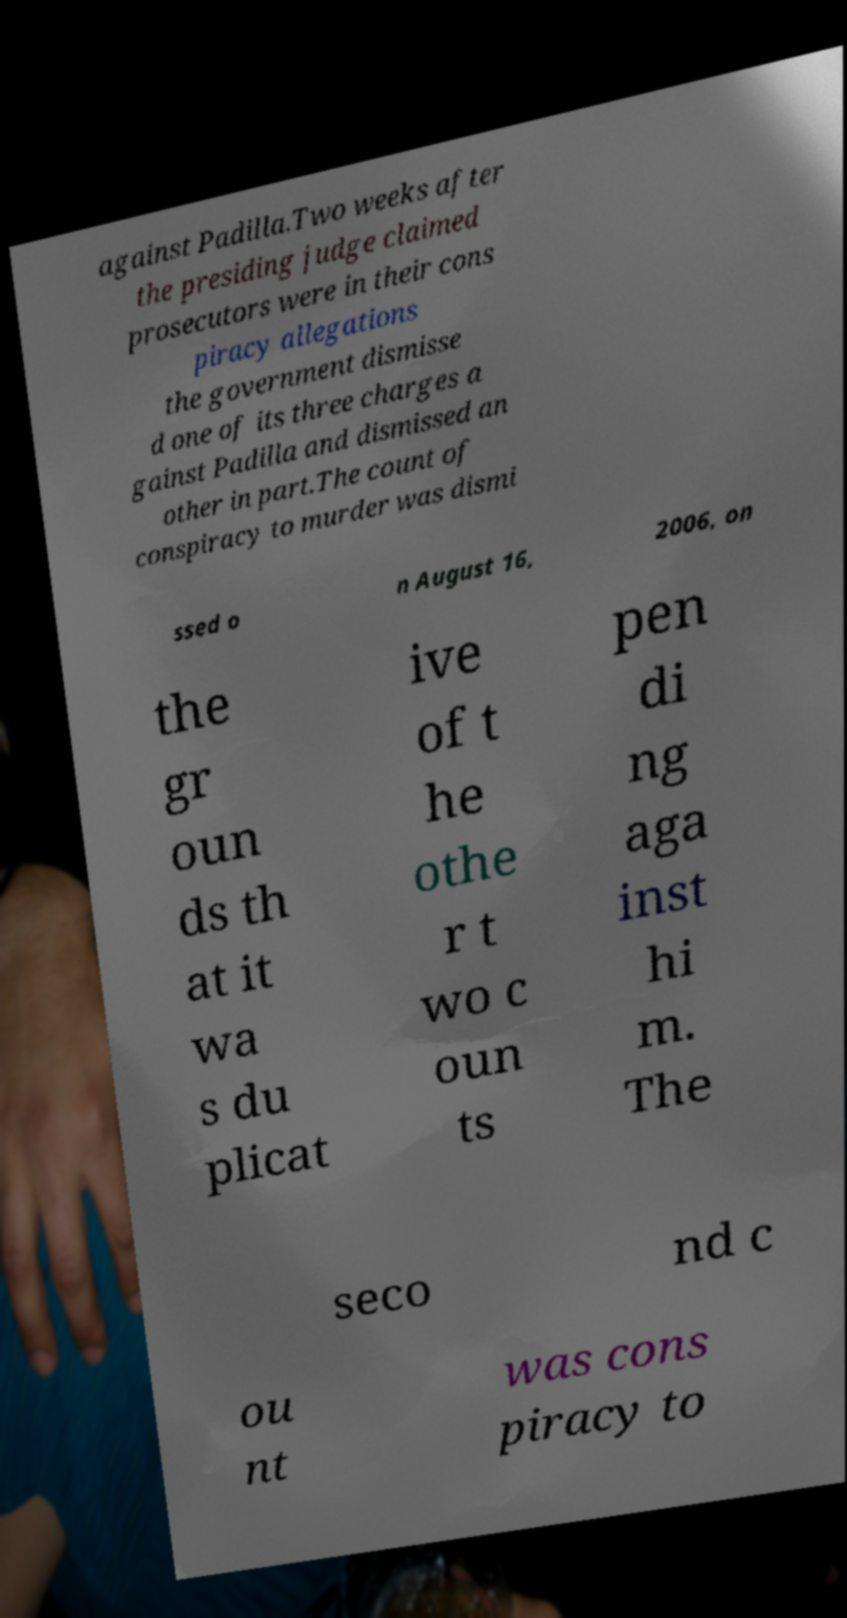Can you accurately transcribe the text from the provided image for me? against Padilla.Two weeks after the presiding judge claimed prosecutors were in their cons piracy allegations the government dismisse d one of its three charges a gainst Padilla and dismissed an other in part.The count of conspiracy to murder was dismi ssed o n August 16, 2006, on the gr oun ds th at it wa s du plicat ive of t he othe r t wo c oun ts pen di ng aga inst hi m. The seco nd c ou nt was cons piracy to 